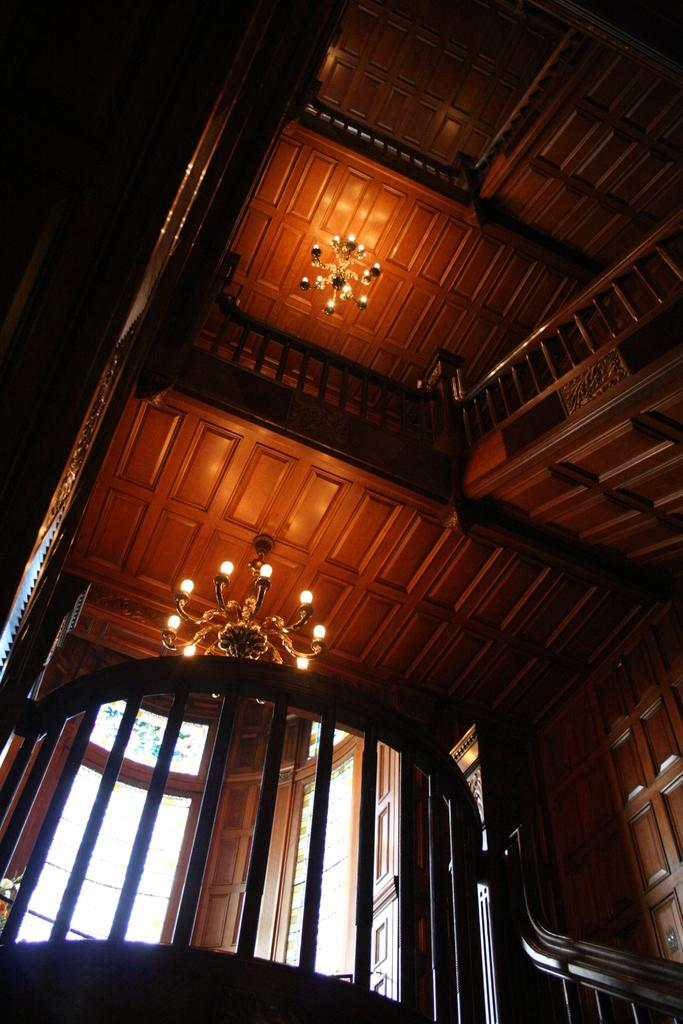Where was the image taken? The image was taken inside a room. What can be seen in the center of the picture? There are chandeliers, windows, and railing in the center of the picture. What type of wooden objects are present in the center of the picture? There are other wooden objects in the center of the picture. What architectural feature is visible on the right side of the picture? There are staircases on the right side of the picture. What type of spark can be seen coming from the railing in the image? There is no spark coming from the railing in the image. How many drops of water are visible on the windows in the image? There is no mention of water or drops on the windows in the image. 